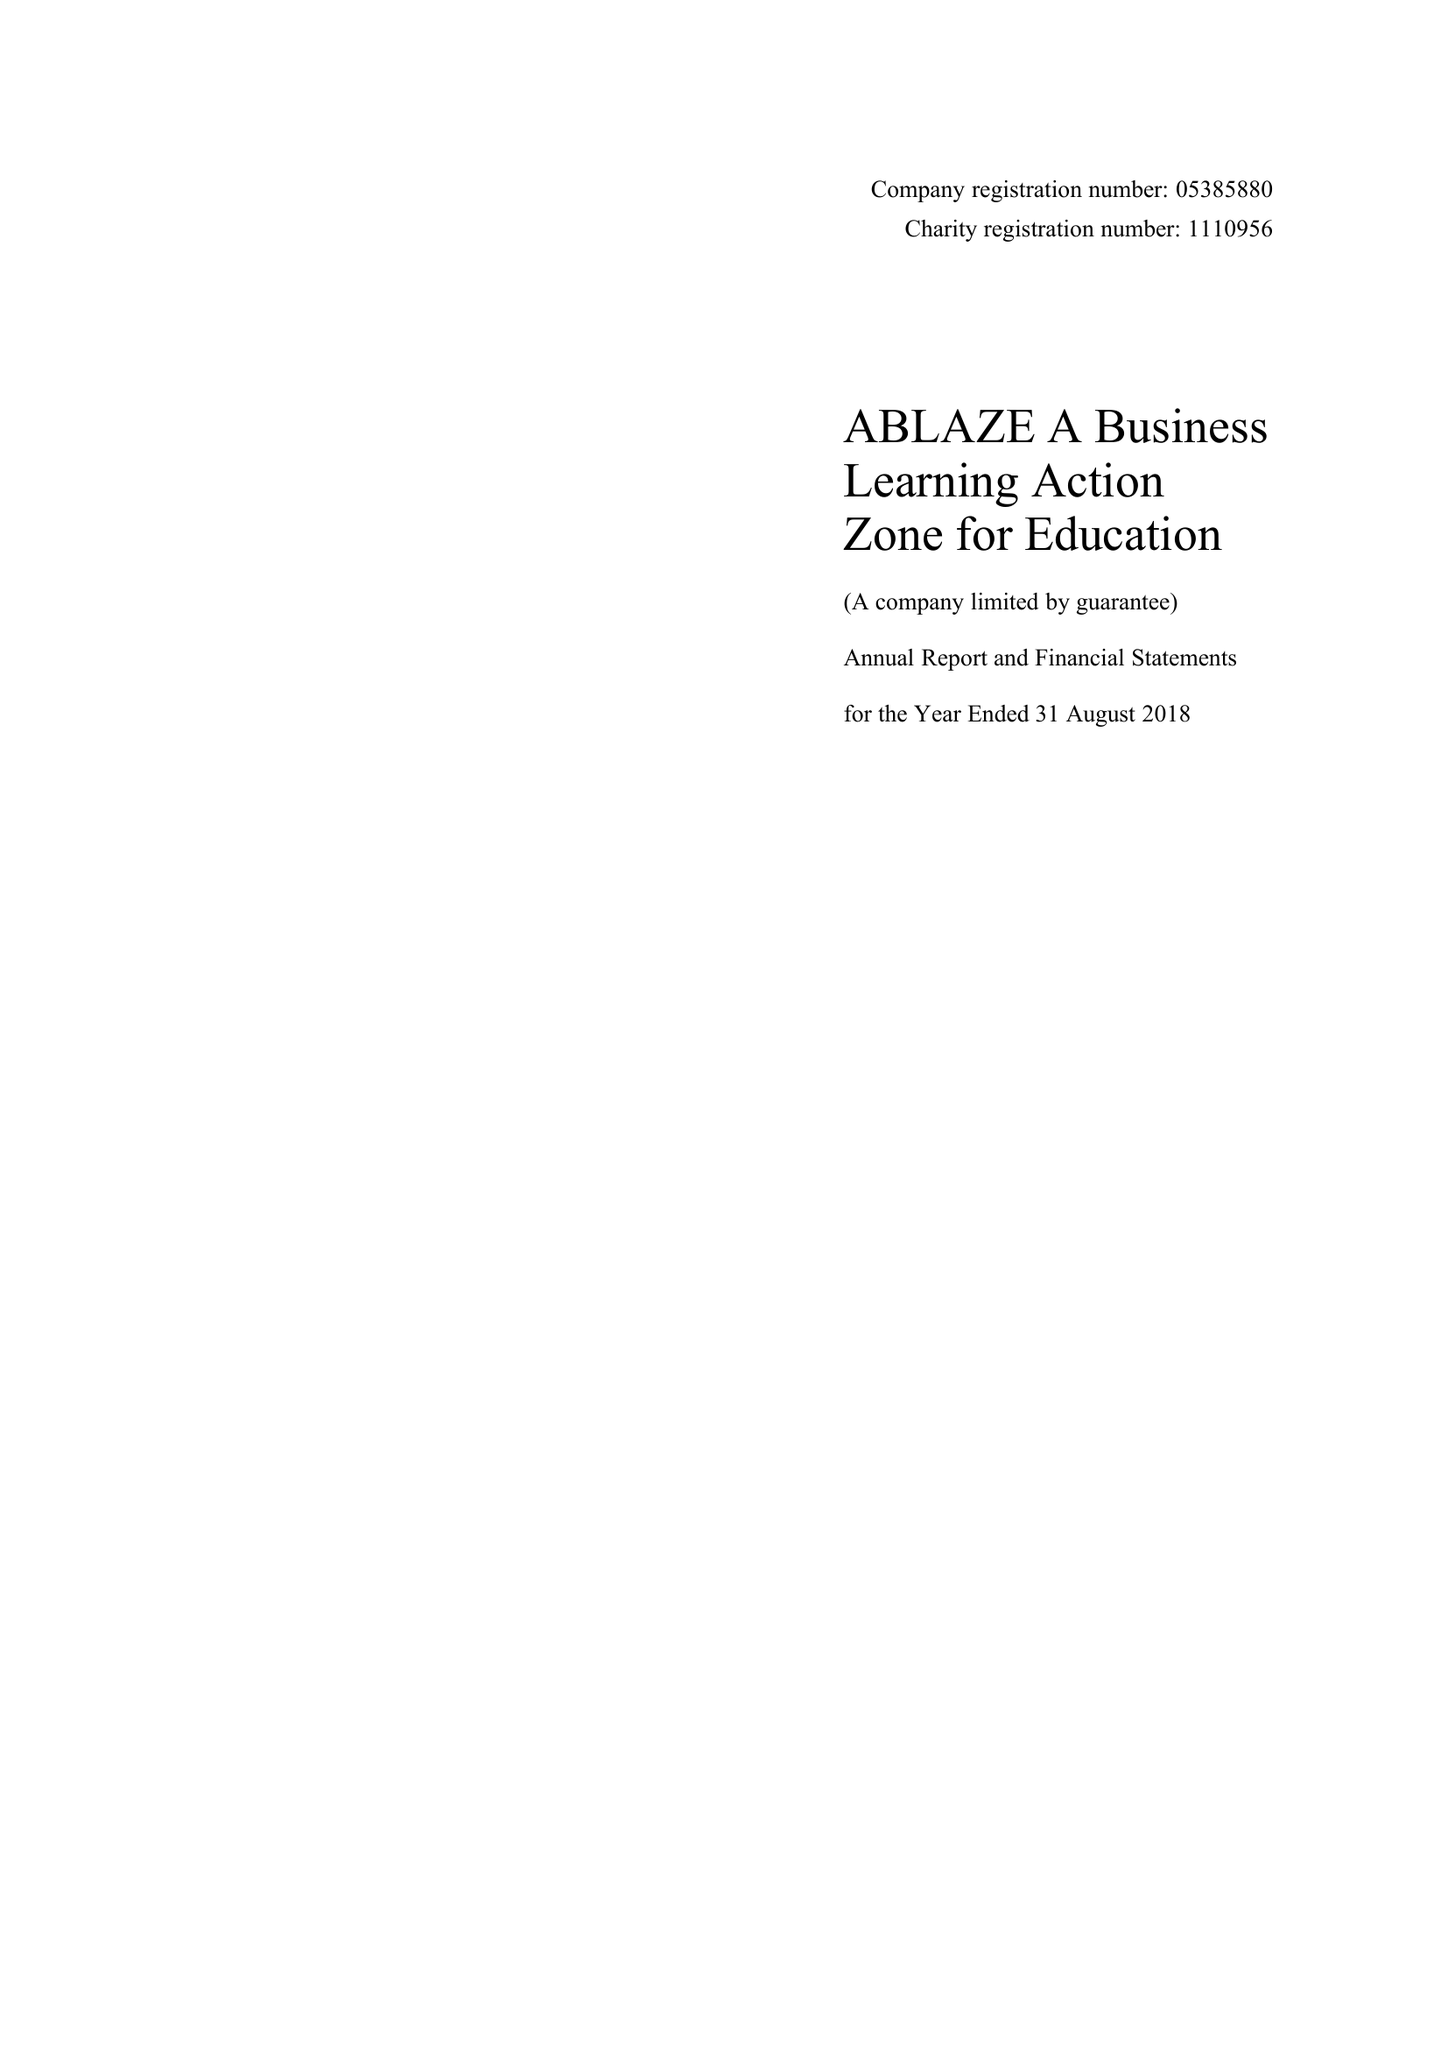What is the value for the address__street_line?
Answer the question using a single word or phrase. REDCLIFFE WAY 